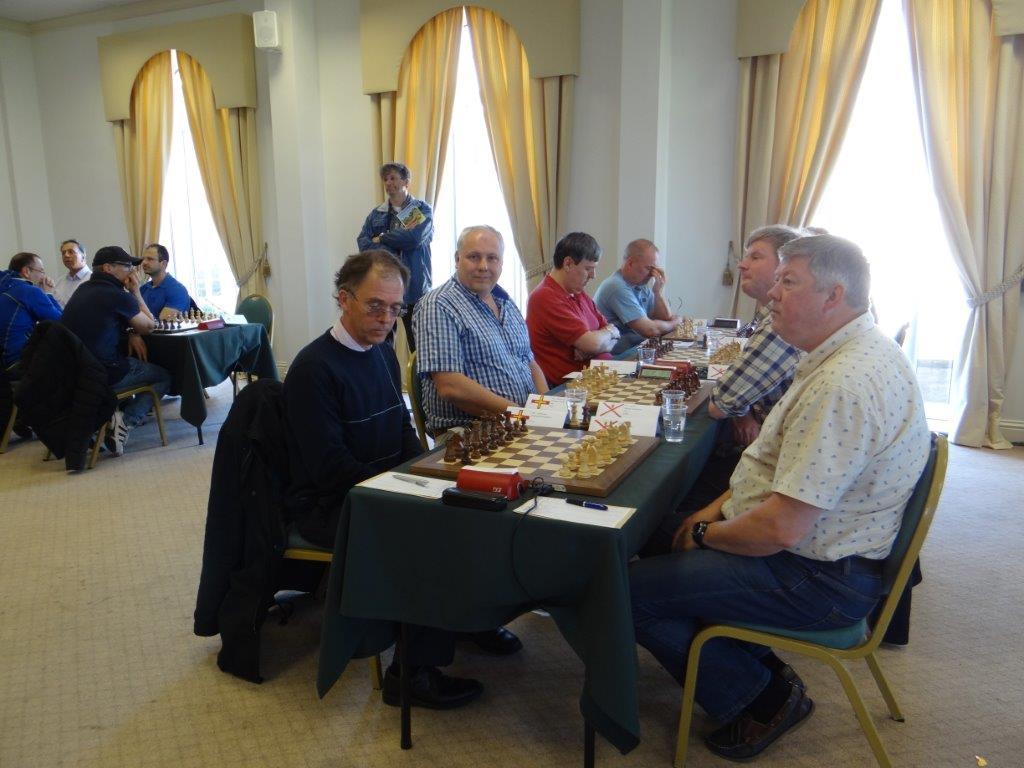Please provide a concise description of this image. In the image we can see there are people who are sitting on chair and on the table there are chess boards with coins and glasses are kept. A man is standing over here and people are sitting on the chair. 